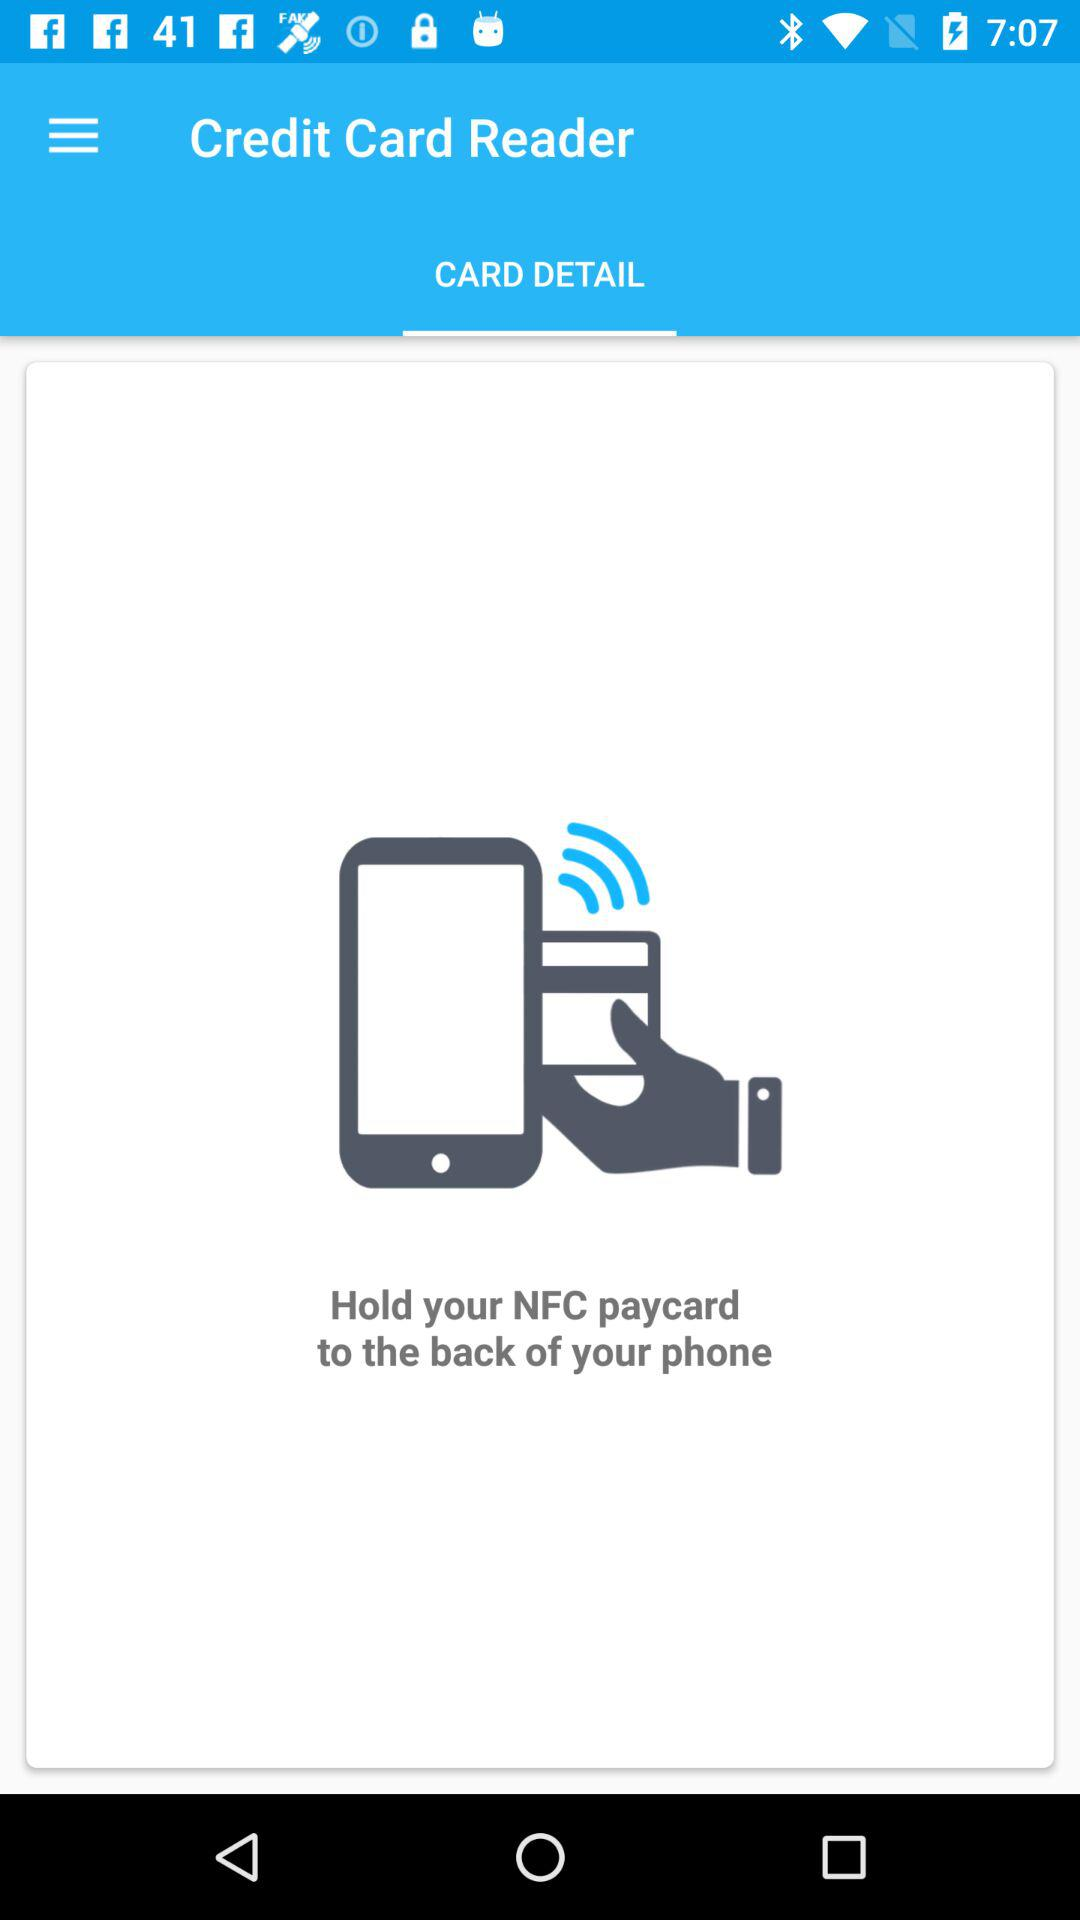What is the selected tab? The selected tab is "CARD DETAIL". 